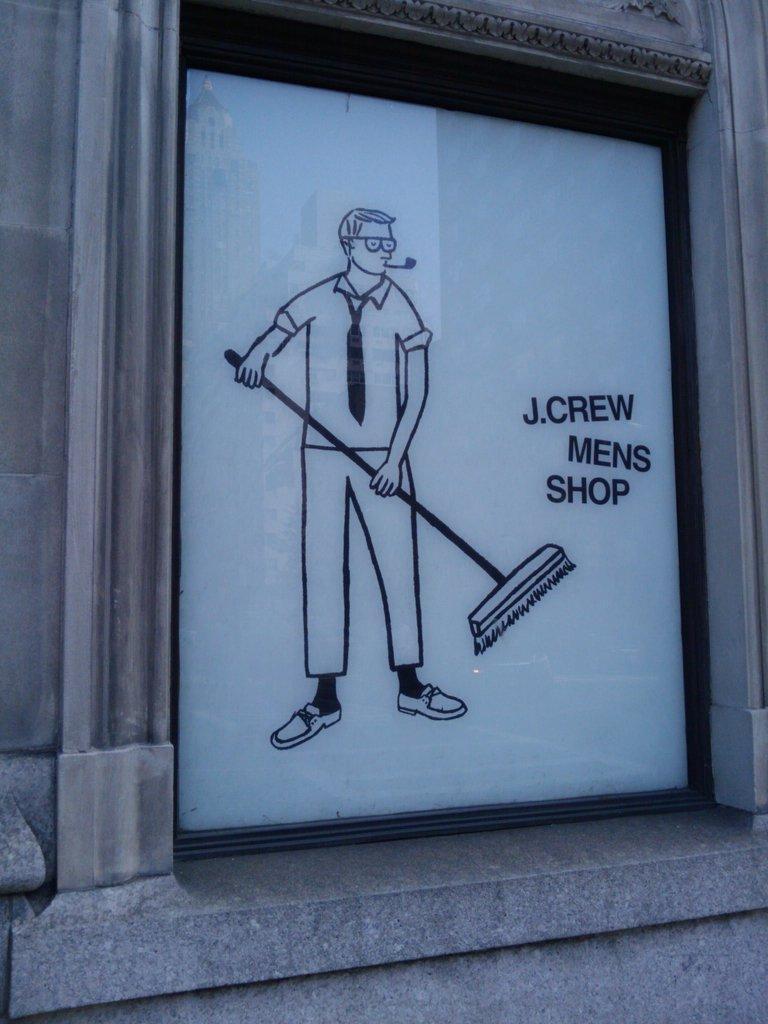Please provide a concise description of this image. In the image there is a painting on the wall with a man holding a broomstick. 